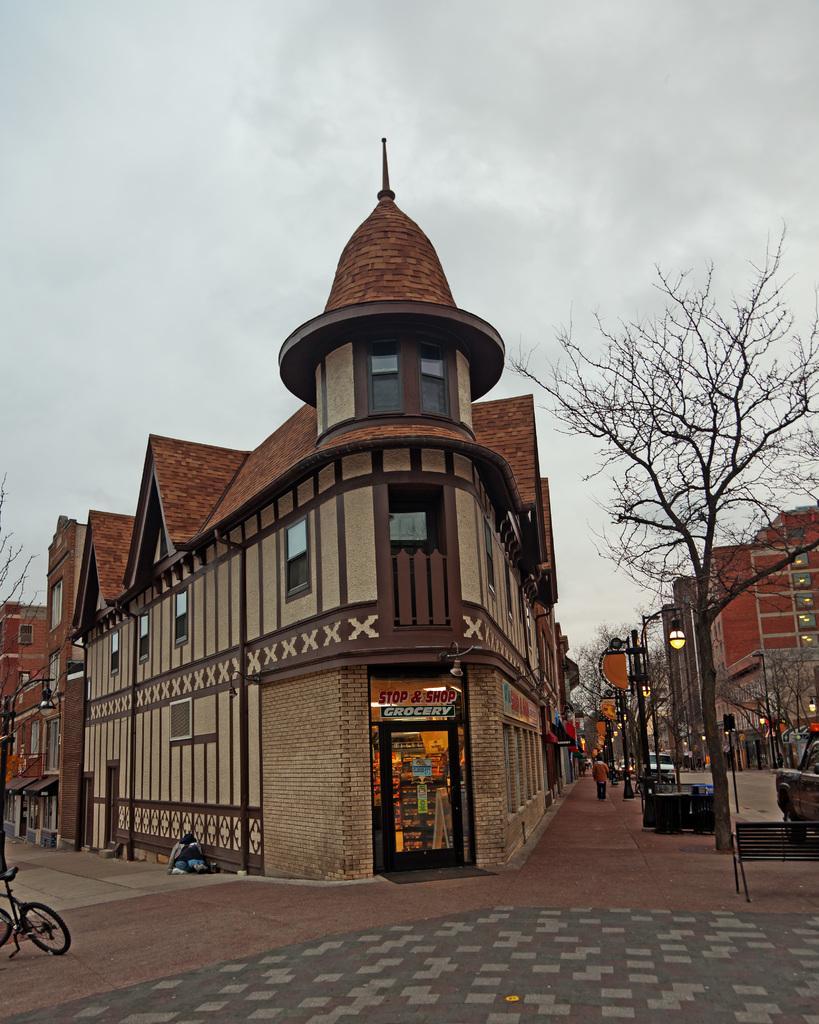Please provide a concise description of this image. In this picture there are buildings and trees and there are street lights. On the right side of the image there are vehicles on the road. In the foreground there is a bicycle on the footpath and there might be a person sitting. At the top there is sky. At the bottom there is a road. 